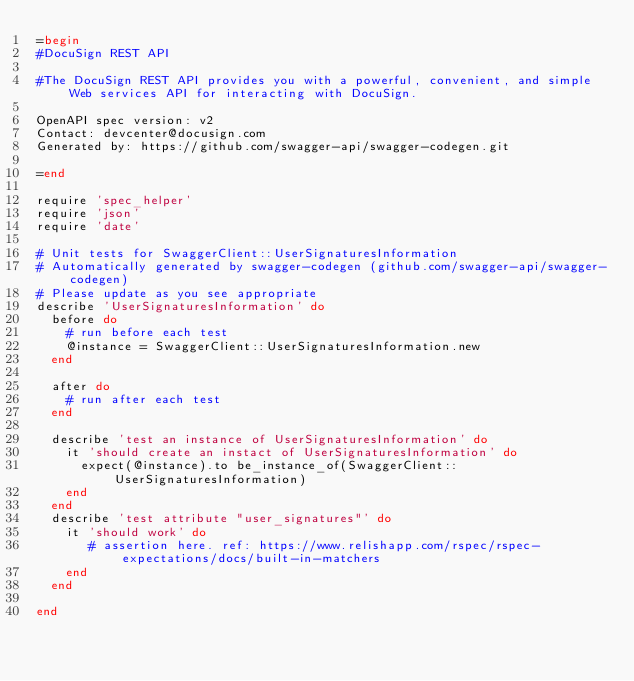<code> <loc_0><loc_0><loc_500><loc_500><_Ruby_>=begin
#DocuSign REST API

#The DocuSign REST API provides you with a powerful, convenient, and simple Web services API for interacting with DocuSign.

OpenAPI spec version: v2
Contact: devcenter@docusign.com
Generated by: https://github.com/swagger-api/swagger-codegen.git

=end

require 'spec_helper'
require 'json'
require 'date'

# Unit tests for SwaggerClient::UserSignaturesInformation
# Automatically generated by swagger-codegen (github.com/swagger-api/swagger-codegen)
# Please update as you see appropriate
describe 'UserSignaturesInformation' do
  before do
    # run before each test
    @instance = SwaggerClient::UserSignaturesInformation.new
  end

  after do
    # run after each test
  end

  describe 'test an instance of UserSignaturesInformation' do
    it 'should create an instact of UserSignaturesInformation' do
      expect(@instance).to be_instance_of(SwaggerClient::UserSignaturesInformation)
    end
  end
  describe 'test attribute "user_signatures"' do
    it 'should work' do
       # assertion here. ref: https://www.relishapp.com/rspec/rspec-expectations/docs/built-in-matchers
    end
  end

end

</code> 